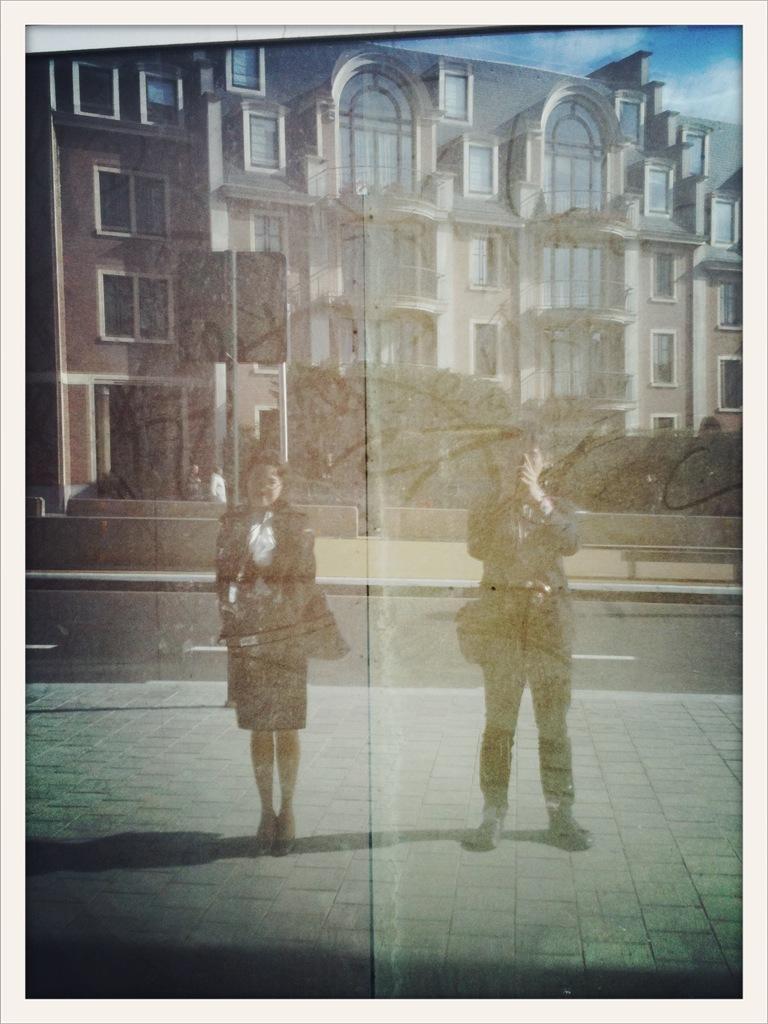In one or two sentences, can you explain what this image depicts? In this image we can see man and woman on the ground. In the background we can see buildings, trees, sky and clouds. 